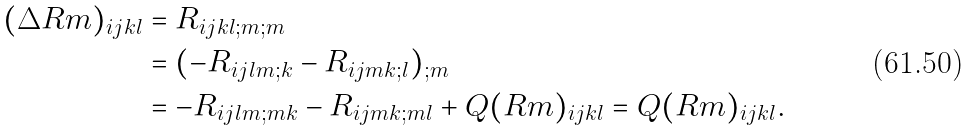Convert formula to latex. <formula><loc_0><loc_0><loc_500><loc_500>( \Delta R m ) _ { i j k l } & = R _ { i j k l ; m ; m } \\ & = ( - R _ { i j l m ; k } - R _ { i j m k ; l } ) _ { ; m } \\ & = - R _ { i j l m ; m k } - R _ { i j m k ; m l } + Q ( R m ) _ { i j k l } = Q ( R m ) _ { i j k l } .</formula> 